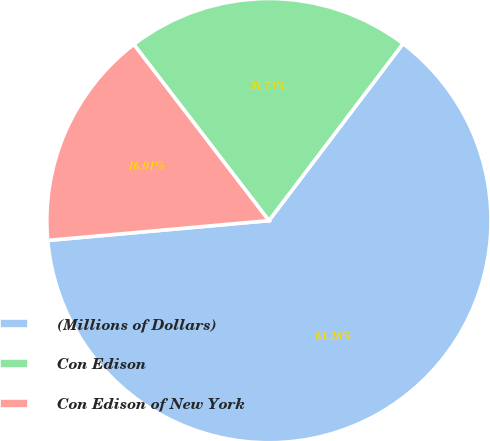Convert chart. <chart><loc_0><loc_0><loc_500><loc_500><pie_chart><fcel>(Millions of Dollars)<fcel>Con Edison<fcel>Con Edison of New York<nl><fcel>63.25%<fcel>20.73%<fcel>16.01%<nl></chart> 